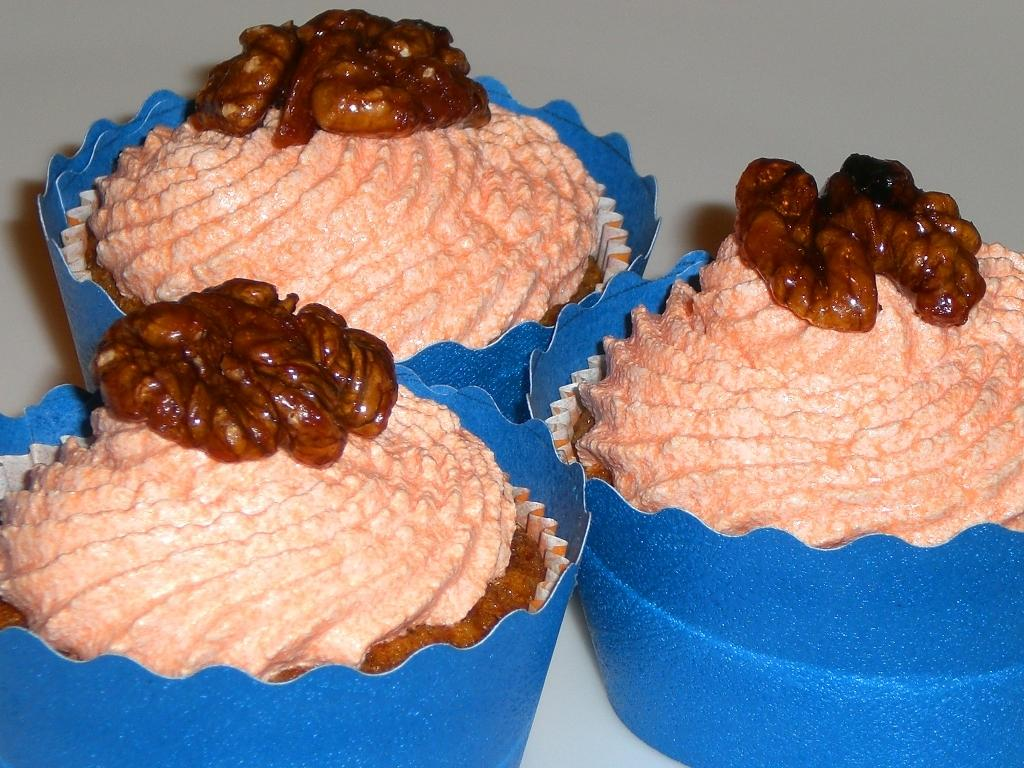How many cupcakes are visible in the image? There are three cupcakes in the image. What type of toothpaste is used to decorate the cupcakes in the image? There is no toothpaste present in the image, as it features cupcakes without any decoration. 